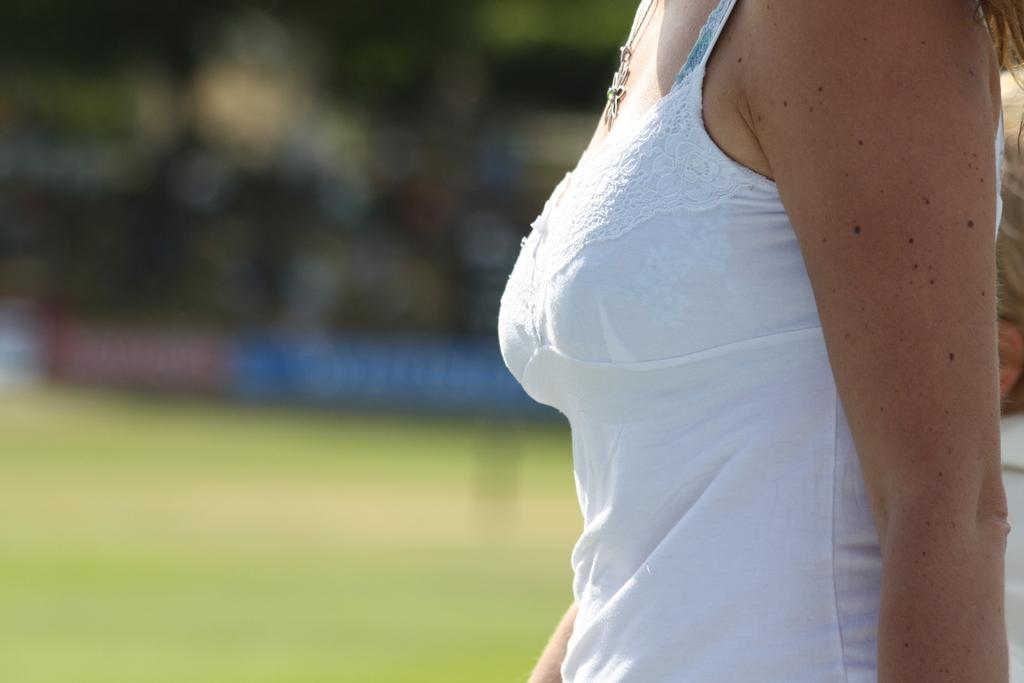Who is the main subject in the image? There is a woman in the image. Where is the woman located in the image? The woman is present on the ground. What type of lace is the woman wearing in the image? There is no mention of lace in the image, so it cannot be determined what type of lace the woman might be wearing. 